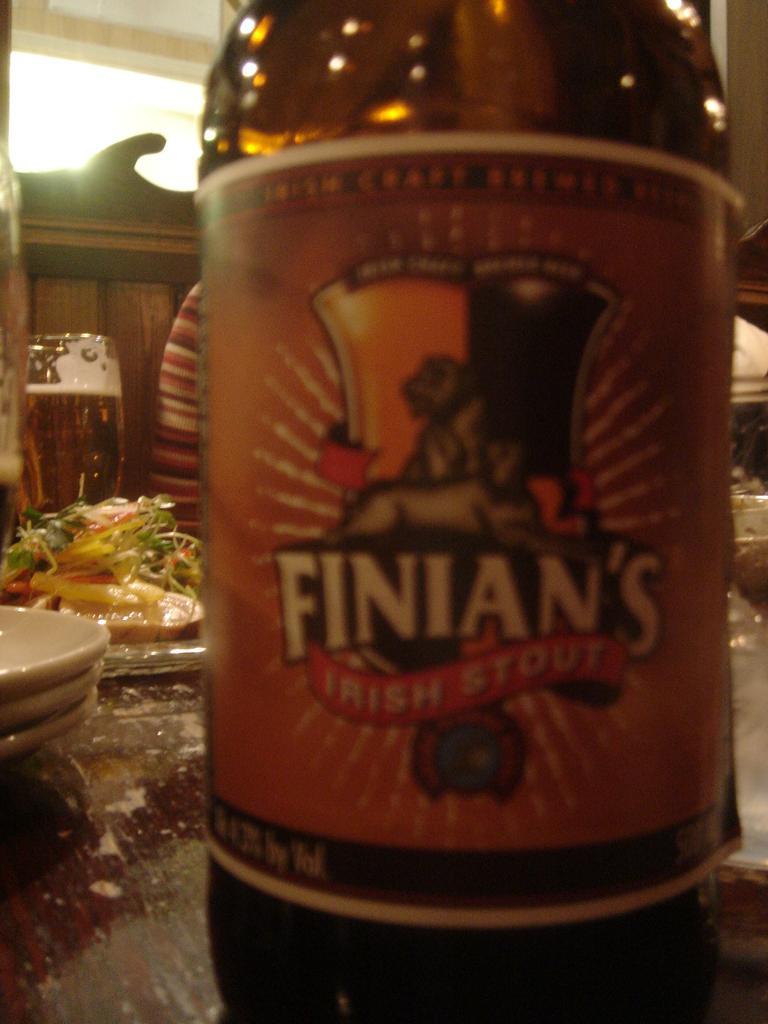What is the brand of this beer?
Offer a very short reply. Finian's. 